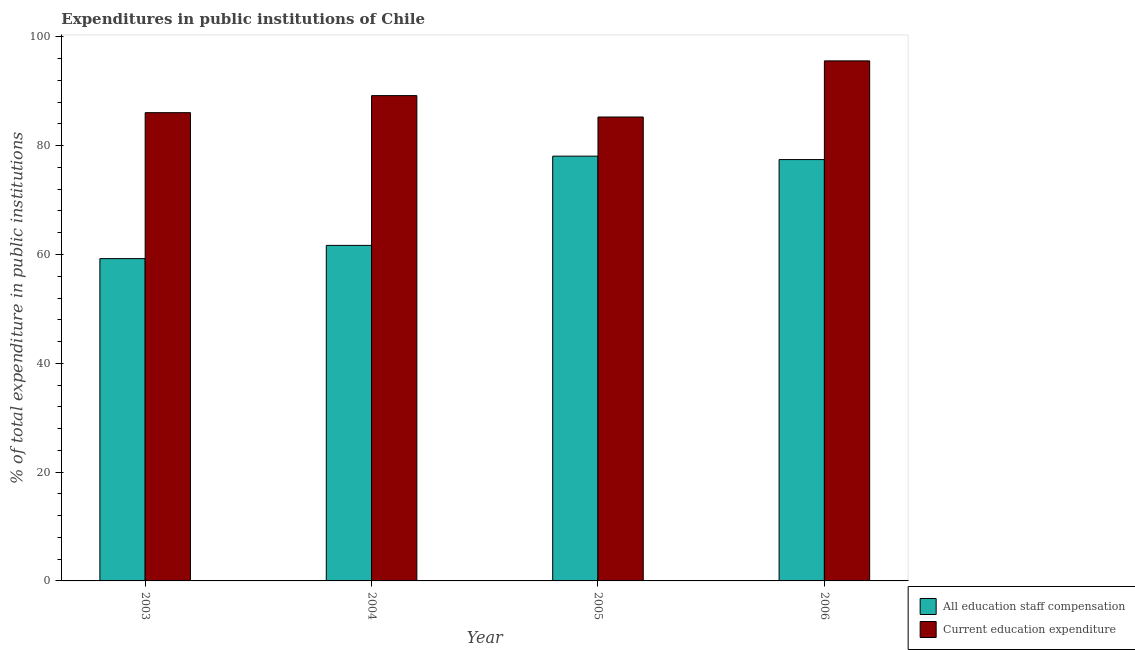How many groups of bars are there?
Provide a short and direct response. 4. Are the number of bars per tick equal to the number of legend labels?
Your answer should be compact. Yes. Are the number of bars on each tick of the X-axis equal?
Keep it short and to the point. Yes. How many bars are there on the 3rd tick from the left?
Your answer should be very brief. 2. How many bars are there on the 1st tick from the right?
Your answer should be compact. 2. In how many cases, is the number of bars for a given year not equal to the number of legend labels?
Ensure brevity in your answer.  0. What is the expenditure in staff compensation in 2003?
Provide a succinct answer. 59.24. Across all years, what is the maximum expenditure in education?
Keep it short and to the point. 95.59. Across all years, what is the minimum expenditure in education?
Provide a short and direct response. 85.27. In which year was the expenditure in staff compensation maximum?
Ensure brevity in your answer.  2005. In which year was the expenditure in education minimum?
Your response must be concise. 2005. What is the total expenditure in education in the graph?
Offer a terse response. 356.13. What is the difference between the expenditure in staff compensation in 2004 and that in 2006?
Provide a succinct answer. -15.77. What is the difference between the expenditure in education in 2006 and the expenditure in staff compensation in 2004?
Make the answer very short. 6.39. What is the average expenditure in education per year?
Offer a terse response. 89.03. What is the ratio of the expenditure in staff compensation in 2004 to that in 2006?
Offer a terse response. 0.8. Is the difference between the expenditure in staff compensation in 2003 and 2006 greater than the difference between the expenditure in education in 2003 and 2006?
Provide a succinct answer. No. What is the difference between the highest and the second highest expenditure in staff compensation?
Offer a terse response. 0.63. What is the difference between the highest and the lowest expenditure in staff compensation?
Offer a very short reply. 18.83. What does the 2nd bar from the left in 2004 represents?
Your response must be concise. Current education expenditure. What does the 1st bar from the right in 2005 represents?
Provide a succinct answer. Current education expenditure. How many bars are there?
Ensure brevity in your answer.  8. What is the difference between two consecutive major ticks on the Y-axis?
Your response must be concise. 20. Are the values on the major ticks of Y-axis written in scientific E-notation?
Provide a short and direct response. No. Does the graph contain grids?
Provide a short and direct response. No. How many legend labels are there?
Ensure brevity in your answer.  2. How are the legend labels stacked?
Your response must be concise. Vertical. What is the title of the graph?
Your answer should be compact. Expenditures in public institutions of Chile. Does "Working only" appear as one of the legend labels in the graph?
Make the answer very short. No. What is the label or title of the X-axis?
Provide a short and direct response. Year. What is the label or title of the Y-axis?
Offer a very short reply. % of total expenditure in public institutions. What is the % of total expenditure in public institutions in All education staff compensation in 2003?
Give a very brief answer. 59.24. What is the % of total expenditure in public institutions in Current education expenditure in 2003?
Provide a short and direct response. 86.07. What is the % of total expenditure in public institutions in All education staff compensation in 2004?
Your answer should be very brief. 61.67. What is the % of total expenditure in public institutions in Current education expenditure in 2004?
Your answer should be compact. 89.2. What is the % of total expenditure in public institutions in All education staff compensation in 2005?
Give a very brief answer. 78.08. What is the % of total expenditure in public institutions in Current education expenditure in 2005?
Make the answer very short. 85.27. What is the % of total expenditure in public institutions in All education staff compensation in 2006?
Provide a succinct answer. 77.45. What is the % of total expenditure in public institutions in Current education expenditure in 2006?
Provide a succinct answer. 95.59. Across all years, what is the maximum % of total expenditure in public institutions in All education staff compensation?
Make the answer very short. 78.08. Across all years, what is the maximum % of total expenditure in public institutions of Current education expenditure?
Ensure brevity in your answer.  95.59. Across all years, what is the minimum % of total expenditure in public institutions in All education staff compensation?
Your answer should be compact. 59.24. Across all years, what is the minimum % of total expenditure in public institutions of Current education expenditure?
Give a very brief answer. 85.27. What is the total % of total expenditure in public institutions of All education staff compensation in the graph?
Ensure brevity in your answer.  276.44. What is the total % of total expenditure in public institutions of Current education expenditure in the graph?
Your answer should be compact. 356.13. What is the difference between the % of total expenditure in public institutions of All education staff compensation in 2003 and that in 2004?
Provide a succinct answer. -2.43. What is the difference between the % of total expenditure in public institutions in Current education expenditure in 2003 and that in 2004?
Offer a terse response. -3.13. What is the difference between the % of total expenditure in public institutions of All education staff compensation in 2003 and that in 2005?
Give a very brief answer. -18.83. What is the difference between the % of total expenditure in public institutions of Current education expenditure in 2003 and that in 2005?
Keep it short and to the point. 0.8. What is the difference between the % of total expenditure in public institutions of All education staff compensation in 2003 and that in 2006?
Give a very brief answer. -18.2. What is the difference between the % of total expenditure in public institutions in Current education expenditure in 2003 and that in 2006?
Offer a terse response. -9.52. What is the difference between the % of total expenditure in public institutions in All education staff compensation in 2004 and that in 2005?
Provide a succinct answer. -16.4. What is the difference between the % of total expenditure in public institutions in Current education expenditure in 2004 and that in 2005?
Your answer should be very brief. 3.93. What is the difference between the % of total expenditure in public institutions of All education staff compensation in 2004 and that in 2006?
Your answer should be very brief. -15.77. What is the difference between the % of total expenditure in public institutions of Current education expenditure in 2004 and that in 2006?
Give a very brief answer. -6.39. What is the difference between the % of total expenditure in public institutions of All education staff compensation in 2005 and that in 2006?
Your answer should be compact. 0.63. What is the difference between the % of total expenditure in public institutions of Current education expenditure in 2005 and that in 2006?
Keep it short and to the point. -10.32. What is the difference between the % of total expenditure in public institutions of All education staff compensation in 2003 and the % of total expenditure in public institutions of Current education expenditure in 2004?
Offer a terse response. -29.96. What is the difference between the % of total expenditure in public institutions of All education staff compensation in 2003 and the % of total expenditure in public institutions of Current education expenditure in 2005?
Ensure brevity in your answer.  -26.03. What is the difference between the % of total expenditure in public institutions in All education staff compensation in 2003 and the % of total expenditure in public institutions in Current education expenditure in 2006?
Your answer should be compact. -36.35. What is the difference between the % of total expenditure in public institutions in All education staff compensation in 2004 and the % of total expenditure in public institutions in Current education expenditure in 2005?
Your answer should be compact. -23.6. What is the difference between the % of total expenditure in public institutions in All education staff compensation in 2004 and the % of total expenditure in public institutions in Current education expenditure in 2006?
Offer a very short reply. -33.91. What is the difference between the % of total expenditure in public institutions in All education staff compensation in 2005 and the % of total expenditure in public institutions in Current education expenditure in 2006?
Give a very brief answer. -17.51. What is the average % of total expenditure in public institutions in All education staff compensation per year?
Your answer should be very brief. 69.11. What is the average % of total expenditure in public institutions of Current education expenditure per year?
Ensure brevity in your answer.  89.03. In the year 2003, what is the difference between the % of total expenditure in public institutions in All education staff compensation and % of total expenditure in public institutions in Current education expenditure?
Your answer should be compact. -26.83. In the year 2004, what is the difference between the % of total expenditure in public institutions in All education staff compensation and % of total expenditure in public institutions in Current education expenditure?
Give a very brief answer. -27.53. In the year 2005, what is the difference between the % of total expenditure in public institutions in All education staff compensation and % of total expenditure in public institutions in Current education expenditure?
Provide a short and direct response. -7.19. In the year 2006, what is the difference between the % of total expenditure in public institutions of All education staff compensation and % of total expenditure in public institutions of Current education expenditure?
Keep it short and to the point. -18.14. What is the ratio of the % of total expenditure in public institutions in All education staff compensation in 2003 to that in 2004?
Give a very brief answer. 0.96. What is the ratio of the % of total expenditure in public institutions in Current education expenditure in 2003 to that in 2004?
Provide a succinct answer. 0.96. What is the ratio of the % of total expenditure in public institutions of All education staff compensation in 2003 to that in 2005?
Your answer should be compact. 0.76. What is the ratio of the % of total expenditure in public institutions of Current education expenditure in 2003 to that in 2005?
Provide a succinct answer. 1.01. What is the ratio of the % of total expenditure in public institutions of All education staff compensation in 2003 to that in 2006?
Ensure brevity in your answer.  0.76. What is the ratio of the % of total expenditure in public institutions of Current education expenditure in 2003 to that in 2006?
Your answer should be compact. 0.9. What is the ratio of the % of total expenditure in public institutions of All education staff compensation in 2004 to that in 2005?
Your answer should be very brief. 0.79. What is the ratio of the % of total expenditure in public institutions in Current education expenditure in 2004 to that in 2005?
Make the answer very short. 1.05. What is the ratio of the % of total expenditure in public institutions of All education staff compensation in 2004 to that in 2006?
Offer a very short reply. 0.8. What is the ratio of the % of total expenditure in public institutions in Current education expenditure in 2004 to that in 2006?
Give a very brief answer. 0.93. What is the ratio of the % of total expenditure in public institutions of All education staff compensation in 2005 to that in 2006?
Provide a succinct answer. 1.01. What is the ratio of the % of total expenditure in public institutions in Current education expenditure in 2005 to that in 2006?
Offer a very short reply. 0.89. What is the difference between the highest and the second highest % of total expenditure in public institutions of All education staff compensation?
Offer a very short reply. 0.63. What is the difference between the highest and the second highest % of total expenditure in public institutions in Current education expenditure?
Ensure brevity in your answer.  6.39. What is the difference between the highest and the lowest % of total expenditure in public institutions of All education staff compensation?
Your response must be concise. 18.83. What is the difference between the highest and the lowest % of total expenditure in public institutions in Current education expenditure?
Provide a succinct answer. 10.32. 